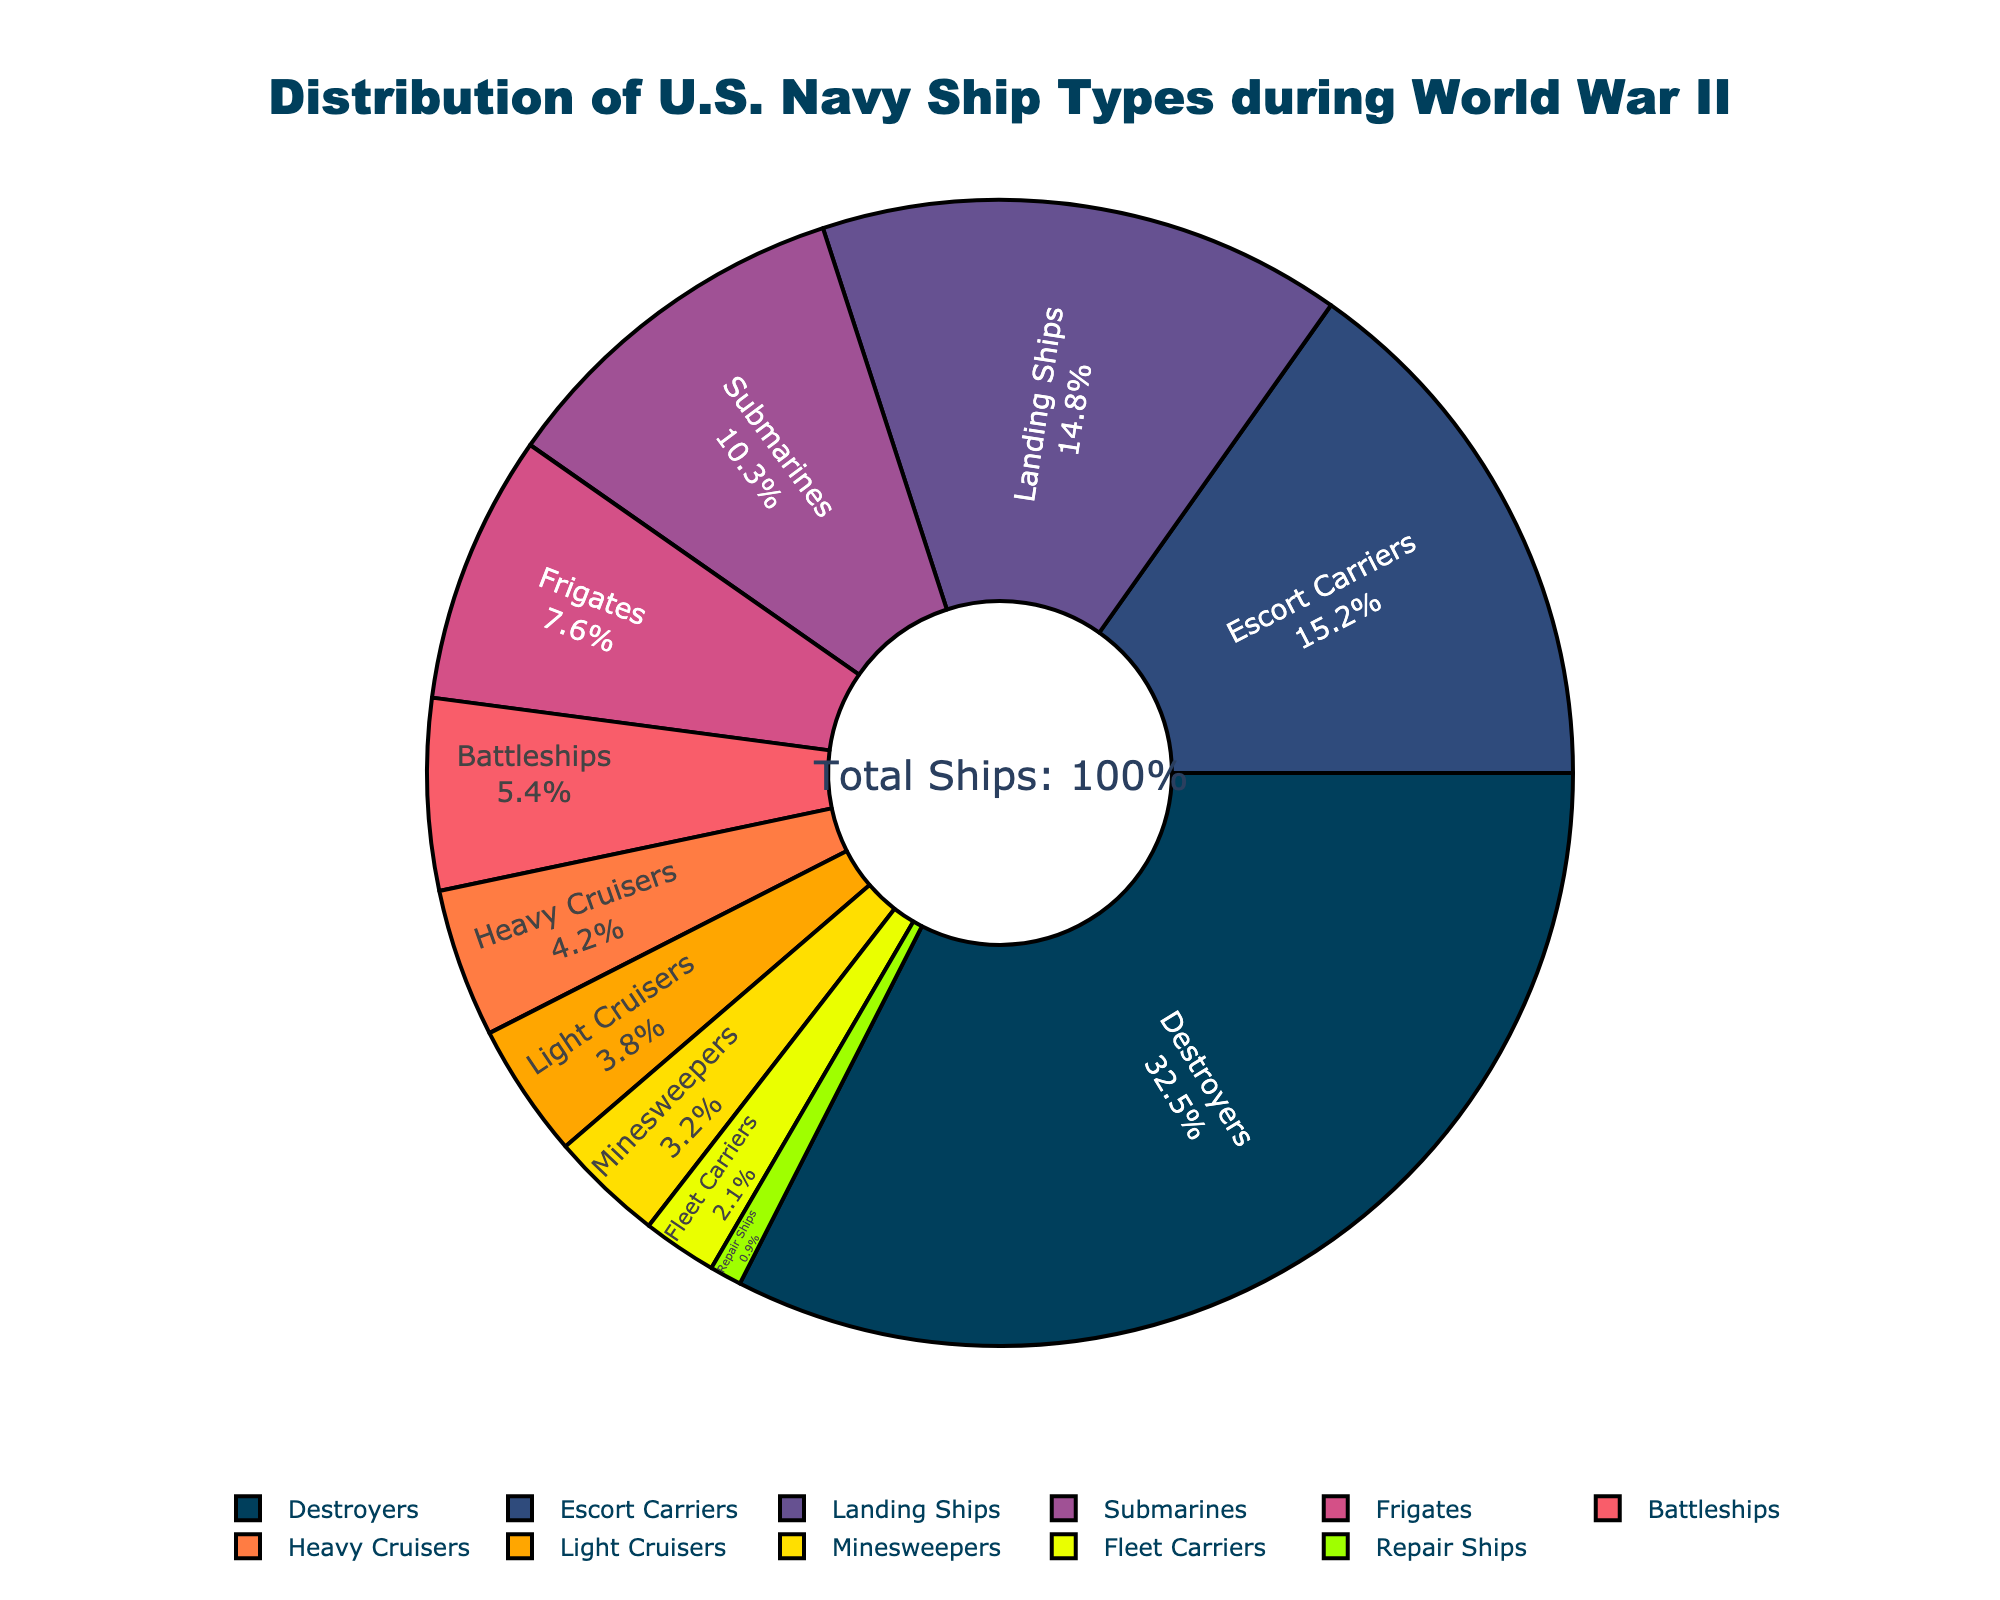What percentage of ship types were Destroyers and Escort Carriers combined? The percentage of Destroyers is 32.5% and Escort Carriers is 15.2%. Adding these gives 32.5 + 15.2 = 47.7%.
Answer: 47.7% Is the percentage of Landing Ships greater than the combined percentage of Frigates and Heavy Cruisers? The percentage of Landing Ships is 14.8%. The combined percentage of Frigates (7.6%) and Heavy Cruisers (4.2%) is 7.6 + 4.2 = 11.8%. Thus, 14.8% is greater than 11.8%.
Answer: Yes Which ship type occupies the smallest percentage of the chart, and what is that percentage? The Repair Ships occupy the smallest percentage of the chart at 0.9%. This can be seen by identifying the smallest segment in the pie chart.
Answer: Repair Ships, 0.9% How does the percentage of Fleet Carriers compare to that of Minesweepers? The percentage of Fleet Carriers is 2.1%, whereas Minesweepers have a percentage of 3.2%. Thus, Fleet Carriers have a smaller percentage than Minesweepers.
Answer: Fleet Carriers < Minesweepers What is the difference in percentage between Submarines and Light Cruisers? The percentage of Submarines is 10.3% and Light Cruisers is 3.8%. Subtracting these gives 10.3 - 3.8 = 6.5%.
Answer: 6.5% What is the total percentage contributed by heavy tonnage ships (Battleships and Heavy Cruisers)? The percentage of Battleships is 5.4%, and Heavy Cruisers is 4.2%. Adding these gives 5.4 + 4.2 = 9.6%.
Answer: 9.6% Which ship type is represented by the yellow segment in the pie chart? By looking at the colors provided, the yellow segment corresponds to Fleet Carriers.
Answer: Fleet Carriers Are there more Destroyers or Escort Carriers, and by what percentage? Destroyers make up 32.5% and Escort Carriers 15.2%. The difference is 32.5 - 15.2 = 17.3%, indicating that there are 17.3% more Destroyers.
Answer: Destroyers, 17.3% What ship type is represented by the purple segment, and what is its percentage? Looking at the colors from the data, the purple segment corresponds to Heavy Cruisers, which have a percentage of 4.2%.
Answer: Heavy Cruisers, 4.2% 